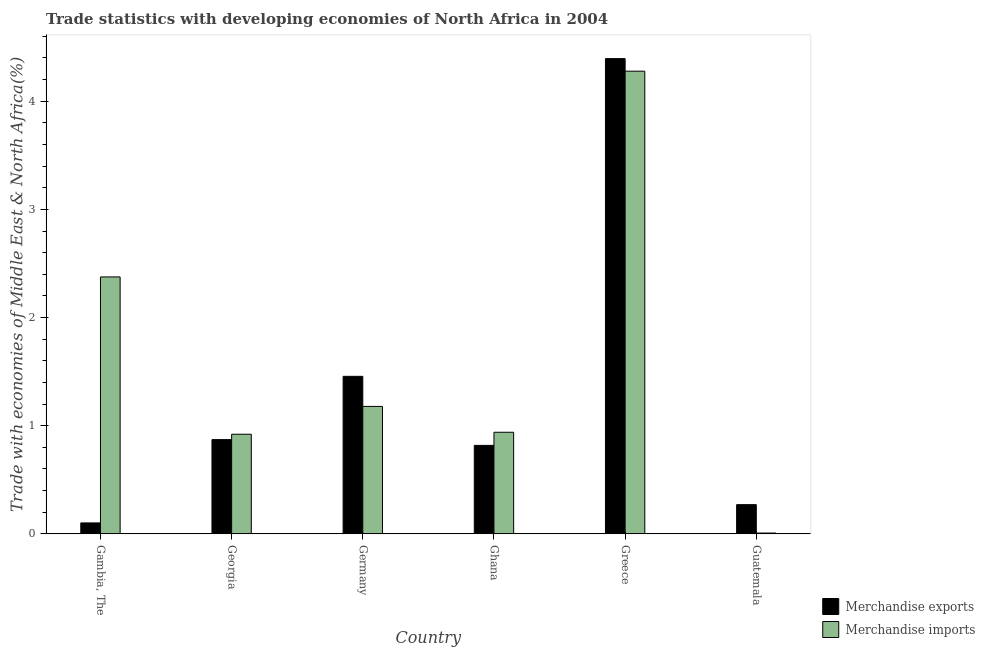How many different coloured bars are there?
Offer a very short reply. 2. How many groups of bars are there?
Provide a succinct answer. 6. In how many cases, is the number of bars for a given country not equal to the number of legend labels?
Offer a very short reply. 0. What is the merchandise exports in Georgia?
Offer a very short reply. 0.87. Across all countries, what is the maximum merchandise imports?
Your answer should be very brief. 4.28. Across all countries, what is the minimum merchandise imports?
Your response must be concise. 0.01. In which country was the merchandise exports minimum?
Provide a short and direct response. Gambia, The. What is the total merchandise exports in the graph?
Your answer should be compact. 7.91. What is the difference between the merchandise exports in Gambia, The and that in Germany?
Keep it short and to the point. -1.36. What is the difference between the merchandise exports in Gambia, The and the merchandise imports in Guatemala?
Keep it short and to the point. 0.09. What is the average merchandise exports per country?
Provide a short and direct response. 1.32. What is the difference between the merchandise imports and merchandise exports in Gambia, The?
Your answer should be very brief. 2.27. What is the ratio of the merchandise imports in Gambia, The to that in Germany?
Your answer should be very brief. 2.02. What is the difference between the highest and the second highest merchandise imports?
Your response must be concise. 1.9. What is the difference between the highest and the lowest merchandise imports?
Your answer should be very brief. 4.27. What does the 2nd bar from the left in Germany represents?
Offer a terse response. Merchandise imports. Are all the bars in the graph horizontal?
Your answer should be very brief. No. How many countries are there in the graph?
Keep it short and to the point. 6. What is the difference between two consecutive major ticks on the Y-axis?
Provide a short and direct response. 1. Are the values on the major ticks of Y-axis written in scientific E-notation?
Make the answer very short. No. Does the graph contain any zero values?
Make the answer very short. No. Does the graph contain grids?
Keep it short and to the point. No. How many legend labels are there?
Your answer should be compact. 2. How are the legend labels stacked?
Give a very brief answer. Vertical. What is the title of the graph?
Ensure brevity in your answer.  Trade statistics with developing economies of North Africa in 2004. What is the label or title of the X-axis?
Keep it short and to the point. Country. What is the label or title of the Y-axis?
Make the answer very short. Trade with economies of Middle East & North Africa(%). What is the Trade with economies of Middle East & North Africa(%) of Merchandise exports in Gambia, The?
Make the answer very short. 0.1. What is the Trade with economies of Middle East & North Africa(%) in Merchandise imports in Gambia, The?
Provide a succinct answer. 2.38. What is the Trade with economies of Middle East & North Africa(%) of Merchandise exports in Georgia?
Give a very brief answer. 0.87. What is the Trade with economies of Middle East & North Africa(%) in Merchandise imports in Georgia?
Provide a succinct answer. 0.92. What is the Trade with economies of Middle East & North Africa(%) of Merchandise exports in Germany?
Offer a terse response. 1.46. What is the Trade with economies of Middle East & North Africa(%) in Merchandise imports in Germany?
Your answer should be very brief. 1.18. What is the Trade with economies of Middle East & North Africa(%) of Merchandise exports in Ghana?
Your answer should be compact. 0.82. What is the Trade with economies of Middle East & North Africa(%) in Merchandise imports in Ghana?
Ensure brevity in your answer.  0.94. What is the Trade with economies of Middle East & North Africa(%) of Merchandise exports in Greece?
Give a very brief answer. 4.39. What is the Trade with economies of Middle East & North Africa(%) in Merchandise imports in Greece?
Provide a short and direct response. 4.28. What is the Trade with economies of Middle East & North Africa(%) of Merchandise exports in Guatemala?
Keep it short and to the point. 0.27. What is the Trade with economies of Middle East & North Africa(%) in Merchandise imports in Guatemala?
Ensure brevity in your answer.  0.01. Across all countries, what is the maximum Trade with economies of Middle East & North Africa(%) of Merchandise exports?
Keep it short and to the point. 4.39. Across all countries, what is the maximum Trade with economies of Middle East & North Africa(%) of Merchandise imports?
Make the answer very short. 4.28. Across all countries, what is the minimum Trade with economies of Middle East & North Africa(%) of Merchandise exports?
Offer a terse response. 0.1. Across all countries, what is the minimum Trade with economies of Middle East & North Africa(%) of Merchandise imports?
Provide a succinct answer. 0.01. What is the total Trade with economies of Middle East & North Africa(%) in Merchandise exports in the graph?
Give a very brief answer. 7.91. What is the total Trade with economies of Middle East & North Africa(%) of Merchandise imports in the graph?
Offer a very short reply. 9.7. What is the difference between the Trade with economies of Middle East & North Africa(%) in Merchandise exports in Gambia, The and that in Georgia?
Provide a short and direct response. -0.77. What is the difference between the Trade with economies of Middle East & North Africa(%) in Merchandise imports in Gambia, The and that in Georgia?
Provide a short and direct response. 1.45. What is the difference between the Trade with economies of Middle East & North Africa(%) of Merchandise exports in Gambia, The and that in Germany?
Offer a terse response. -1.36. What is the difference between the Trade with economies of Middle East & North Africa(%) in Merchandise imports in Gambia, The and that in Germany?
Provide a short and direct response. 1.2. What is the difference between the Trade with economies of Middle East & North Africa(%) in Merchandise exports in Gambia, The and that in Ghana?
Make the answer very short. -0.72. What is the difference between the Trade with economies of Middle East & North Africa(%) of Merchandise imports in Gambia, The and that in Ghana?
Keep it short and to the point. 1.44. What is the difference between the Trade with economies of Middle East & North Africa(%) in Merchandise exports in Gambia, The and that in Greece?
Your response must be concise. -4.29. What is the difference between the Trade with economies of Middle East & North Africa(%) of Merchandise imports in Gambia, The and that in Greece?
Offer a terse response. -1.9. What is the difference between the Trade with economies of Middle East & North Africa(%) of Merchandise exports in Gambia, The and that in Guatemala?
Ensure brevity in your answer.  -0.17. What is the difference between the Trade with economies of Middle East & North Africa(%) in Merchandise imports in Gambia, The and that in Guatemala?
Give a very brief answer. 2.37. What is the difference between the Trade with economies of Middle East & North Africa(%) of Merchandise exports in Georgia and that in Germany?
Your response must be concise. -0.59. What is the difference between the Trade with economies of Middle East & North Africa(%) of Merchandise imports in Georgia and that in Germany?
Offer a terse response. -0.26. What is the difference between the Trade with economies of Middle East & North Africa(%) of Merchandise exports in Georgia and that in Ghana?
Offer a terse response. 0.05. What is the difference between the Trade with economies of Middle East & North Africa(%) in Merchandise imports in Georgia and that in Ghana?
Your answer should be very brief. -0.02. What is the difference between the Trade with economies of Middle East & North Africa(%) of Merchandise exports in Georgia and that in Greece?
Provide a short and direct response. -3.52. What is the difference between the Trade with economies of Middle East & North Africa(%) of Merchandise imports in Georgia and that in Greece?
Offer a very short reply. -3.36. What is the difference between the Trade with economies of Middle East & North Africa(%) of Merchandise exports in Georgia and that in Guatemala?
Provide a short and direct response. 0.6. What is the difference between the Trade with economies of Middle East & North Africa(%) in Merchandise imports in Georgia and that in Guatemala?
Give a very brief answer. 0.91. What is the difference between the Trade with economies of Middle East & North Africa(%) in Merchandise exports in Germany and that in Ghana?
Offer a terse response. 0.64. What is the difference between the Trade with economies of Middle East & North Africa(%) in Merchandise imports in Germany and that in Ghana?
Offer a terse response. 0.24. What is the difference between the Trade with economies of Middle East & North Africa(%) of Merchandise exports in Germany and that in Greece?
Give a very brief answer. -2.94. What is the difference between the Trade with economies of Middle East & North Africa(%) in Merchandise imports in Germany and that in Greece?
Your answer should be very brief. -3.1. What is the difference between the Trade with economies of Middle East & North Africa(%) of Merchandise exports in Germany and that in Guatemala?
Make the answer very short. 1.19. What is the difference between the Trade with economies of Middle East & North Africa(%) in Merchandise imports in Germany and that in Guatemala?
Offer a terse response. 1.17. What is the difference between the Trade with economies of Middle East & North Africa(%) of Merchandise exports in Ghana and that in Greece?
Ensure brevity in your answer.  -3.58. What is the difference between the Trade with economies of Middle East & North Africa(%) of Merchandise imports in Ghana and that in Greece?
Your answer should be compact. -3.34. What is the difference between the Trade with economies of Middle East & North Africa(%) of Merchandise exports in Ghana and that in Guatemala?
Provide a succinct answer. 0.55. What is the difference between the Trade with economies of Middle East & North Africa(%) in Merchandise imports in Ghana and that in Guatemala?
Offer a very short reply. 0.93. What is the difference between the Trade with economies of Middle East & North Africa(%) of Merchandise exports in Greece and that in Guatemala?
Give a very brief answer. 4.12. What is the difference between the Trade with economies of Middle East & North Africa(%) in Merchandise imports in Greece and that in Guatemala?
Offer a terse response. 4.27. What is the difference between the Trade with economies of Middle East & North Africa(%) in Merchandise exports in Gambia, The and the Trade with economies of Middle East & North Africa(%) in Merchandise imports in Georgia?
Provide a succinct answer. -0.82. What is the difference between the Trade with economies of Middle East & North Africa(%) in Merchandise exports in Gambia, The and the Trade with economies of Middle East & North Africa(%) in Merchandise imports in Germany?
Give a very brief answer. -1.08. What is the difference between the Trade with economies of Middle East & North Africa(%) of Merchandise exports in Gambia, The and the Trade with economies of Middle East & North Africa(%) of Merchandise imports in Ghana?
Ensure brevity in your answer.  -0.84. What is the difference between the Trade with economies of Middle East & North Africa(%) in Merchandise exports in Gambia, The and the Trade with economies of Middle East & North Africa(%) in Merchandise imports in Greece?
Keep it short and to the point. -4.18. What is the difference between the Trade with economies of Middle East & North Africa(%) of Merchandise exports in Gambia, The and the Trade with economies of Middle East & North Africa(%) of Merchandise imports in Guatemala?
Keep it short and to the point. 0.09. What is the difference between the Trade with economies of Middle East & North Africa(%) of Merchandise exports in Georgia and the Trade with economies of Middle East & North Africa(%) of Merchandise imports in Germany?
Ensure brevity in your answer.  -0.31. What is the difference between the Trade with economies of Middle East & North Africa(%) of Merchandise exports in Georgia and the Trade with economies of Middle East & North Africa(%) of Merchandise imports in Ghana?
Make the answer very short. -0.07. What is the difference between the Trade with economies of Middle East & North Africa(%) of Merchandise exports in Georgia and the Trade with economies of Middle East & North Africa(%) of Merchandise imports in Greece?
Provide a short and direct response. -3.41. What is the difference between the Trade with economies of Middle East & North Africa(%) in Merchandise exports in Georgia and the Trade with economies of Middle East & North Africa(%) in Merchandise imports in Guatemala?
Offer a very short reply. 0.86. What is the difference between the Trade with economies of Middle East & North Africa(%) in Merchandise exports in Germany and the Trade with economies of Middle East & North Africa(%) in Merchandise imports in Ghana?
Provide a succinct answer. 0.52. What is the difference between the Trade with economies of Middle East & North Africa(%) of Merchandise exports in Germany and the Trade with economies of Middle East & North Africa(%) of Merchandise imports in Greece?
Ensure brevity in your answer.  -2.82. What is the difference between the Trade with economies of Middle East & North Africa(%) of Merchandise exports in Germany and the Trade with economies of Middle East & North Africa(%) of Merchandise imports in Guatemala?
Your answer should be compact. 1.45. What is the difference between the Trade with economies of Middle East & North Africa(%) in Merchandise exports in Ghana and the Trade with economies of Middle East & North Africa(%) in Merchandise imports in Greece?
Provide a short and direct response. -3.46. What is the difference between the Trade with economies of Middle East & North Africa(%) in Merchandise exports in Ghana and the Trade with economies of Middle East & North Africa(%) in Merchandise imports in Guatemala?
Ensure brevity in your answer.  0.81. What is the difference between the Trade with economies of Middle East & North Africa(%) in Merchandise exports in Greece and the Trade with economies of Middle East & North Africa(%) in Merchandise imports in Guatemala?
Ensure brevity in your answer.  4.39. What is the average Trade with economies of Middle East & North Africa(%) in Merchandise exports per country?
Ensure brevity in your answer.  1.32. What is the average Trade with economies of Middle East & North Africa(%) in Merchandise imports per country?
Offer a very short reply. 1.62. What is the difference between the Trade with economies of Middle East & North Africa(%) in Merchandise exports and Trade with economies of Middle East & North Africa(%) in Merchandise imports in Gambia, The?
Provide a succinct answer. -2.27. What is the difference between the Trade with economies of Middle East & North Africa(%) in Merchandise exports and Trade with economies of Middle East & North Africa(%) in Merchandise imports in Georgia?
Ensure brevity in your answer.  -0.05. What is the difference between the Trade with economies of Middle East & North Africa(%) of Merchandise exports and Trade with economies of Middle East & North Africa(%) of Merchandise imports in Germany?
Offer a very short reply. 0.28. What is the difference between the Trade with economies of Middle East & North Africa(%) of Merchandise exports and Trade with economies of Middle East & North Africa(%) of Merchandise imports in Ghana?
Keep it short and to the point. -0.12. What is the difference between the Trade with economies of Middle East & North Africa(%) in Merchandise exports and Trade with economies of Middle East & North Africa(%) in Merchandise imports in Greece?
Give a very brief answer. 0.12. What is the difference between the Trade with economies of Middle East & North Africa(%) of Merchandise exports and Trade with economies of Middle East & North Africa(%) of Merchandise imports in Guatemala?
Provide a succinct answer. 0.26. What is the ratio of the Trade with economies of Middle East & North Africa(%) of Merchandise exports in Gambia, The to that in Georgia?
Give a very brief answer. 0.12. What is the ratio of the Trade with economies of Middle East & North Africa(%) in Merchandise imports in Gambia, The to that in Georgia?
Keep it short and to the point. 2.58. What is the ratio of the Trade with economies of Middle East & North Africa(%) in Merchandise exports in Gambia, The to that in Germany?
Your answer should be compact. 0.07. What is the ratio of the Trade with economies of Middle East & North Africa(%) in Merchandise imports in Gambia, The to that in Germany?
Keep it short and to the point. 2.02. What is the ratio of the Trade with economies of Middle East & North Africa(%) in Merchandise exports in Gambia, The to that in Ghana?
Your answer should be very brief. 0.12. What is the ratio of the Trade with economies of Middle East & North Africa(%) in Merchandise imports in Gambia, The to that in Ghana?
Your answer should be compact. 2.53. What is the ratio of the Trade with economies of Middle East & North Africa(%) in Merchandise exports in Gambia, The to that in Greece?
Give a very brief answer. 0.02. What is the ratio of the Trade with economies of Middle East & North Africa(%) in Merchandise imports in Gambia, The to that in Greece?
Provide a succinct answer. 0.56. What is the ratio of the Trade with economies of Middle East & North Africa(%) of Merchandise exports in Gambia, The to that in Guatemala?
Your answer should be compact. 0.37. What is the ratio of the Trade with economies of Middle East & North Africa(%) in Merchandise imports in Gambia, The to that in Guatemala?
Your answer should be compact. 315.24. What is the ratio of the Trade with economies of Middle East & North Africa(%) in Merchandise exports in Georgia to that in Germany?
Make the answer very short. 0.6. What is the ratio of the Trade with economies of Middle East & North Africa(%) in Merchandise imports in Georgia to that in Germany?
Offer a very short reply. 0.78. What is the ratio of the Trade with economies of Middle East & North Africa(%) in Merchandise exports in Georgia to that in Ghana?
Provide a succinct answer. 1.07. What is the ratio of the Trade with economies of Middle East & North Africa(%) in Merchandise imports in Georgia to that in Ghana?
Provide a short and direct response. 0.98. What is the ratio of the Trade with economies of Middle East & North Africa(%) of Merchandise exports in Georgia to that in Greece?
Your response must be concise. 0.2. What is the ratio of the Trade with economies of Middle East & North Africa(%) of Merchandise imports in Georgia to that in Greece?
Ensure brevity in your answer.  0.22. What is the ratio of the Trade with economies of Middle East & North Africa(%) in Merchandise exports in Georgia to that in Guatemala?
Give a very brief answer. 3.23. What is the ratio of the Trade with economies of Middle East & North Africa(%) in Merchandise imports in Georgia to that in Guatemala?
Your response must be concise. 122.23. What is the ratio of the Trade with economies of Middle East & North Africa(%) in Merchandise exports in Germany to that in Ghana?
Make the answer very short. 1.78. What is the ratio of the Trade with economies of Middle East & North Africa(%) in Merchandise imports in Germany to that in Ghana?
Keep it short and to the point. 1.25. What is the ratio of the Trade with economies of Middle East & North Africa(%) in Merchandise exports in Germany to that in Greece?
Ensure brevity in your answer.  0.33. What is the ratio of the Trade with economies of Middle East & North Africa(%) in Merchandise imports in Germany to that in Greece?
Your answer should be compact. 0.28. What is the ratio of the Trade with economies of Middle East & North Africa(%) in Merchandise exports in Germany to that in Guatemala?
Offer a terse response. 5.39. What is the ratio of the Trade with economies of Middle East & North Africa(%) of Merchandise imports in Germany to that in Guatemala?
Your response must be concise. 156.37. What is the ratio of the Trade with economies of Middle East & North Africa(%) of Merchandise exports in Ghana to that in Greece?
Ensure brevity in your answer.  0.19. What is the ratio of the Trade with economies of Middle East & North Africa(%) in Merchandise imports in Ghana to that in Greece?
Give a very brief answer. 0.22. What is the ratio of the Trade with economies of Middle East & North Africa(%) of Merchandise exports in Ghana to that in Guatemala?
Ensure brevity in your answer.  3.03. What is the ratio of the Trade with economies of Middle East & North Africa(%) in Merchandise imports in Ghana to that in Guatemala?
Offer a terse response. 124.65. What is the ratio of the Trade with economies of Middle East & North Africa(%) of Merchandise exports in Greece to that in Guatemala?
Your response must be concise. 16.26. What is the ratio of the Trade with economies of Middle East & North Africa(%) of Merchandise imports in Greece to that in Guatemala?
Ensure brevity in your answer.  567.67. What is the difference between the highest and the second highest Trade with economies of Middle East & North Africa(%) in Merchandise exports?
Your answer should be compact. 2.94. What is the difference between the highest and the second highest Trade with economies of Middle East & North Africa(%) of Merchandise imports?
Your answer should be compact. 1.9. What is the difference between the highest and the lowest Trade with economies of Middle East & North Africa(%) in Merchandise exports?
Provide a succinct answer. 4.29. What is the difference between the highest and the lowest Trade with economies of Middle East & North Africa(%) in Merchandise imports?
Give a very brief answer. 4.27. 